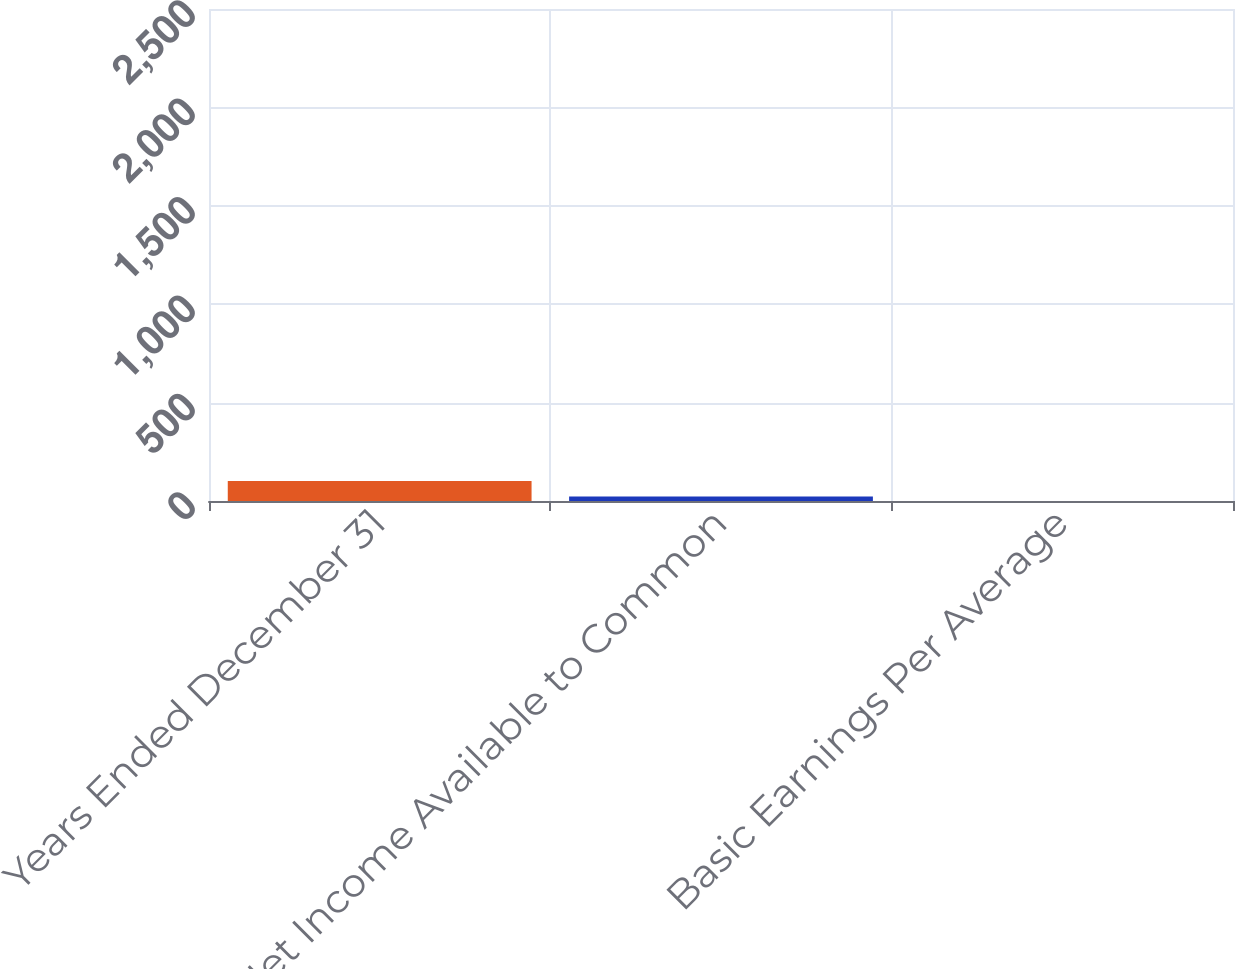<chart> <loc_0><loc_0><loc_500><loc_500><bar_chart><fcel>Years Ended December 31<fcel>Net Income Available to Common<fcel>Basic Earnings Per Average<nl><fcel>2017<fcel>460<fcel>1.64<nl></chart> 